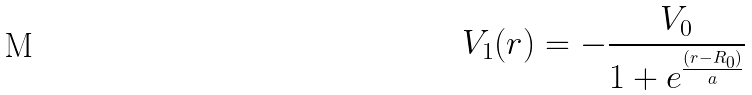Convert formula to latex. <formula><loc_0><loc_0><loc_500><loc_500>V _ { 1 } ( r ) = - \frac { V _ { 0 } } { 1 + e ^ { \frac { ( r - R _ { 0 } ) } { a } } }</formula> 